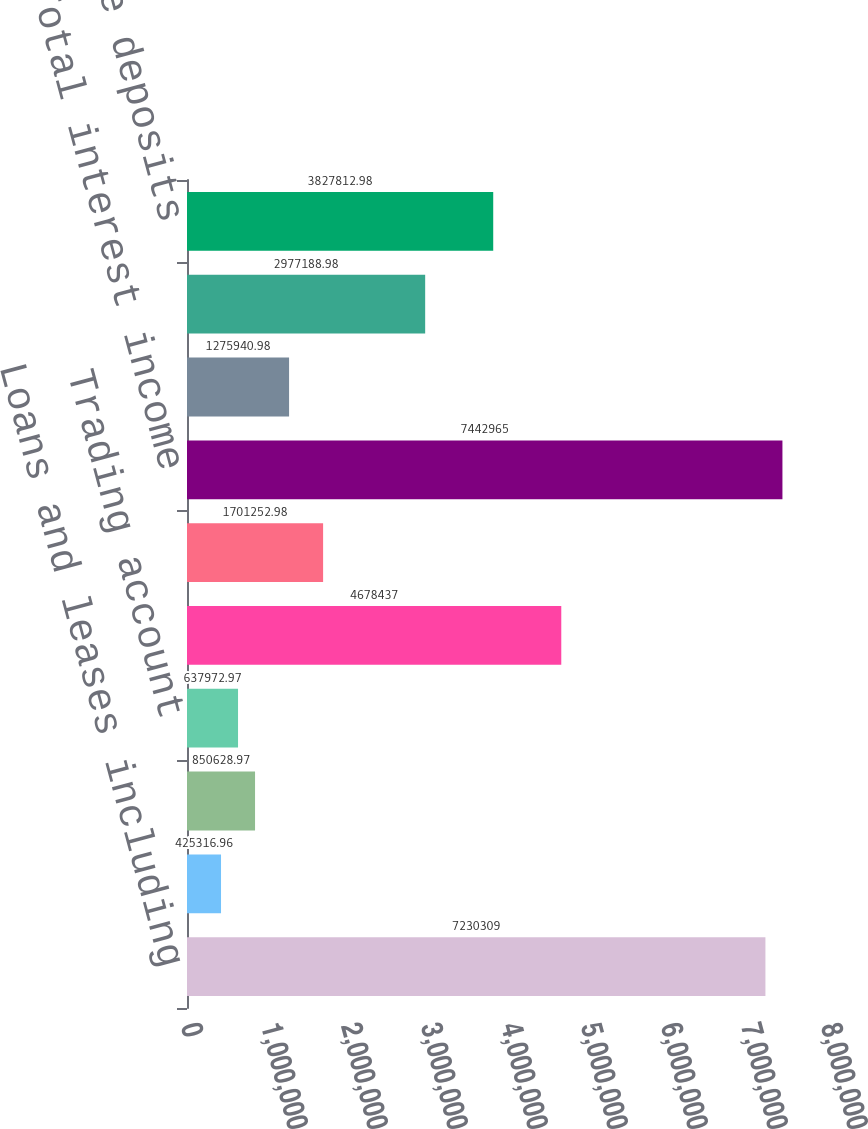Convert chart. <chart><loc_0><loc_0><loc_500><loc_500><bar_chart><fcel>Loans and leases including<fcel>Deposits at banks<fcel>Federal funds sold and<fcel>Trading account<fcel>Fully taxable<fcel>Exempt from federal taxes<fcel>Total interest income<fcel>NOW accounts<fcel>Savings deposits<fcel>Time deposits<nl><fcel>7.23031e+06<fcel>425317<fcel>850629<fcel>637973<fcel>4.67844e+06<fcel>1.70125e+06<fcel>7.44296e+06<fcel>1.27594e+06<fcel>2.97719e+06<fcel>3.82781e+06<nl></chart> 